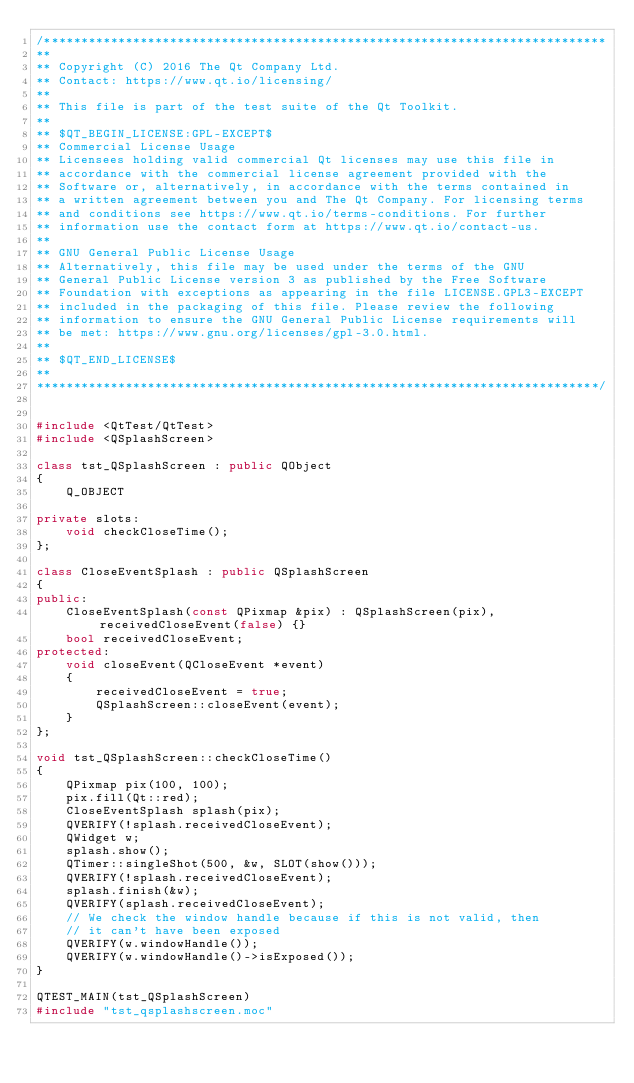<code> <loc_0><loc_0><loc_500><loc_500><_C++_>/****************************************************************************
**
** Copyright (C) 2016 The Qt Company Ltd.
** Contact: https://www.qt.io/licensing/
**
** This file is part of the test suite of the Qt Toolkit.
**
** $QT_BEGIN_LICENSE:GPL-EXCEPT$
** Commercial License Usage
** Licensees holding valid commercial Qt licenses may use this file in
** accordance with the commercial license agreement provided with the
** Software or, alternatively, in accordance with the terms contained in
** a written agreement between you and The Qt Company. For licensing terms
** and conditions see https://www.qt.io/terms-conditions. For further
** information use the contact form at https://www.qt.io/contact-us.
**
** GNU General Public License Usage
** Alternatively, this file may be used under the terms of the GNU
** General Public License version 3 as published by the Free Software
** Foundation with exceptions as appearing in the file LICENSE.GPL3-EXCEPT
** included in the packaging of this file. Please review the following
** information to ensure the GNU General Public License requirements will
** be met: https://www.gnu.org/licenses/gpl-3.0.html.
**
** $QT_END_LICENSE$
**
****************************************************************************/


#include <QtTest/QtTest>
#include <QSplashScreen>

class tst_QSplashScreen : public QObject
{
    Q_OBJECT

private slots:
    void checkCloseTime();
};

class CloseEventSplash : public QSplashScreen
{
public:
    CloseEventSplash(const QPixmap &pix) : QSplashScreen(pix), receivedCloseEvent(false) {}
    bool receivedCloseEvent;
protected:
    void closeEvent(QCloseEvent *event)
    {
        receivedCloseEvent = true;
        QSplashScreen::closeEvent(event);
    }
};

void tst_QSplashScreen::checkCloseTime()
{
    QPixmap pix(100, 100);
    pix.fill(Qt::red);
    CloseEventSplash splash(pix);
    QVERIFY(!splash.receivedCloseEvent);
    QWidget w;
    splash.show();
    QTimer::singleShot(500, &w, SLOT(show()));
    QVERIFY(!splash.receivedCloseEvent);
    splash.finish(&w);
    QVERIFY(splash.receivedCloseEvent);
    // We check the window handle because if this is not valid, then
    // it can't have been exposed
    QVERIFY(w.windowHandle());
    QVERIFY(w.windowHandle()->isExposed());
}

QTEST_MAIN(tst_QSplashScreen)
#include "tst_qsplashscreen.moc"
</code> 